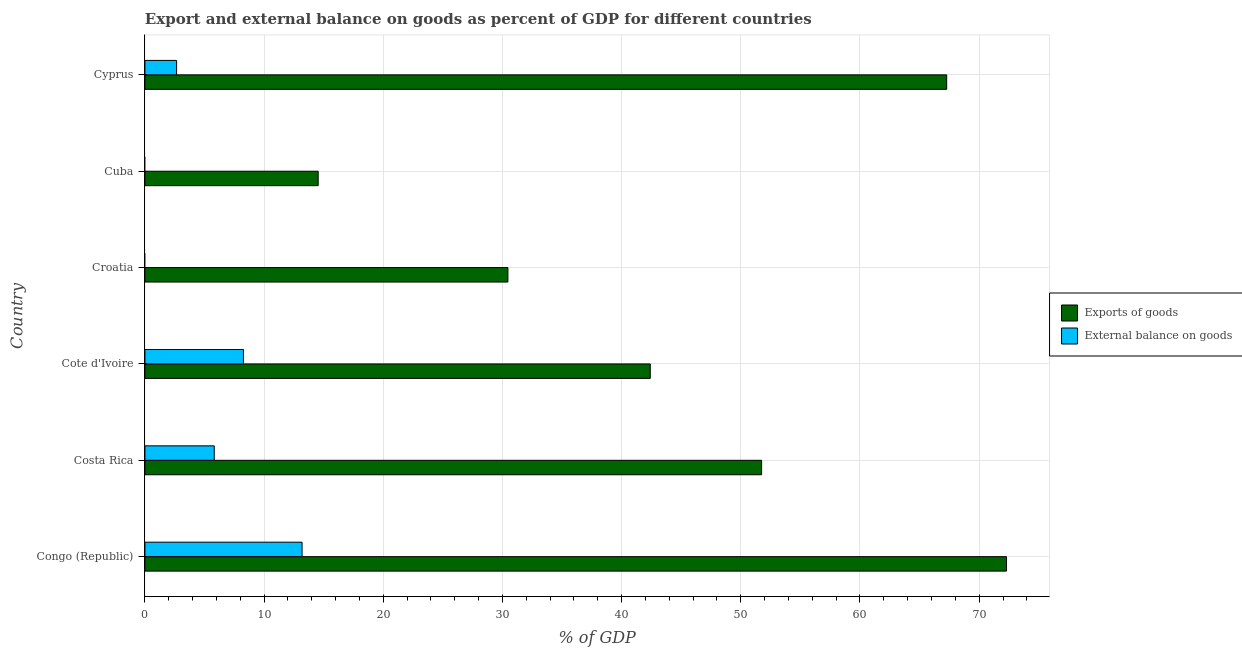How many different coloured bars are there?
Your answer should be very brief. 2. How many bars are there on the 3rd tick from the bottom?
Your response must be concise. 2. What is the label of the 2nd group of bars from the top?
Your response must be concise. Cuba. In how many cases, is the number of bars for a given country not equal to the number of legend labels?
Your answer should be compact. 2. What is the export of goods as percentage of gdp in Cote d'Ivoire?
Provide a succinct answer. 42.4. Across all countries, what is the maximum export of goods as percentage of gdp?
Make the answer very short. 72.29. Across all countries, what is the minimum export of goods as percentage of gdp?
Provide a short and direct response. 14.54. In which country was the external balance on goods as percentage of gdp maximum?
Your response must be concise. Congo (Republic). What is the total external balance on goods as percentage of gdp in the graph?
Provide a succinct answer. 29.93. What is the difference between the external balance on goods as percentage of gdp in Costa Rica and that in Cote d'Ivoire?
Your answer should be compact. -2.45. What is the difference between the export of goods as percentage of gdp in Costa Rica and the external balance on goods as percentage of gdp in Cuba?
Your response must be concise. 51.74. What is the average export of goods as percentage of gdp per country?
Your answer should be compact. 46.45. What is the difference between the external balance on goods as percentage of gdp and export of goods as percentage of gdp in Cote d'Ivoire?
Ensure brevity in your answer.  -34.14. What is the ratio of the export of goods as percentage of gdp in Congo (Republic) to that in Costa Rica?
Your answer should be compact. 1.4. Is the difference between the external balance on goods as percentage of gdp in Cote d'Ivoire and Cyprus greater than the difference between the export of goods as percentage of gdp in Cote d'Ivoire and Cyprus?
Make the answer very short. Yes. What is the difference between the highest and the second highest external balance on goods as percentage of gdp?
Keep it short and to the point. 4.92. What is the difference between the highest and the lowest export of goods as percentage of gdp?
Your answer should be compact. 57.75. How many bars are there?
Ensure brevity in your answer.  10. Are all the bars in the graph horizontal?
Provide a short and direct response. Yes. What is the difference between two consecutive major ticks on the X-axis?
Provide a succinct answer. 10. Does the graph contain any zero values?
Your answer should be very brief. Yes. How many legend labels are there?
Make the answer very short. 2. How are the legend labels stacked?
Your response must be concise. Vertical. What is the title of the graph?
Your answer should be very brief. Export and external balance on goods as percent of GDP for different countries. Does "Male labourers" appear as one of the legend labels in the graph?
Your response must be concise. No. What is the label or title of the X-axis?
Your answer should be very brief. % of GDP. What is the label or title of the Y-axis?
Ensure brevity in your answer.  Country. What is the % of GDP of Exports of goods in Congo (Republic)?
Offer a very short reply. 72.29. What is the % of GDP of External balance on goods in Congo (Republic)?
Offer a very short reply. 13.19. What is the % of GDP in Exports of goods in Costa Rica?
Offer a very short reply. 51.74. What is the % of GDP of External balance on goods in Costa Rica?
Your answer should be compact. 5.82. What is the % of GDP of Exports of goods in Cote d'Ivoire?
Offer a terse response. 42.4. What is the % of GDP in External balance on goods in Cote d'Ivoire?
Your response must be concise. 8.26. What is the % of GDP of Exports of goods in Croatia?
Your answer should be very brief. 30.46. What is the % of GDP of External balance on goods in Croatia?
Your answer should be very brief. 0. What is the % of GDP of Exports of goods in Cuba?
Give a very brief answer. 14.54. What is the % of GDP of Exports of goods in Cyprus?
Provide a short and direct response. 67.27. What is the % of GDP in External balance on goods in Cyprus?
Your answer should be compact. 2.66. Across all countries, what is the maximum % of GDP of Exports of goods?
Make the answer very short. 72.29. Across all countries, what is the maximum % of GDP in External balance on goods?
Your response must be concise. 13.19. Across all countries, what is the minimum % of GDP of Exports of goods?
Give a very brief answer. 14.54. Across all countries, what is the minimum % of GDP in External balance on goods?
Your answer should be very brief. 0. What is the total % of GDP in Exports of goods in the graph?
Keep it short and to the point. 278.71. What is the total % of GDP in External balance on goods in the graph?
Give a very brief answer. 29.93. What is the difference between the % of GDP in Exports of goods in Congo (Republic) and that in Costa Rica?
Your response must be concise. 20.55. What is the difference between the % of GDP in External balance on goods in Congo (Republic) and that in Costa Rica?
Your response must be concise. 7.37. What is the difference between the % of GDP in Exports of goods in Congo (Republic) and that in Cote d'Ivoire?
Offer a very short reply. 29.89. What is the difference between the % of GDP of External balance on goods in Congo (Republic) and that in Cote d'Ivoire?
Provide a succinct answer. 4.92. What is the difference between the % of GDP of Exports of goods in Congo (Republic) and that in Croatia?
Provide a short and direct response. 41.83. What is the difference between the % of GDP in Exports of goods in Congo (Republic) and that in Cuba?
Your answer should be compact. 57.75. What is the difference between the % of GDP in Exports of goods in Congo (Republic) and that in Cyprus?
Your answer should be very brief. 5.02. What is the difference between the % of GDP of External balance on goods in Congo (Republic) and that in Cyprus?
Provide a short and direct response. 10.53. What is the difference between the % of GDP in Exports of goods in Costa Rica and that in Cote d'Ivoire?
Keep it short and to the point. 9.34. What is the difference between the % of GDP in External balance on goods in Costa Rica and that in Cote d'Ivoire?
Make the answer very short. -2.45. What is the difference between the % of GDP in Exports of goods in Costa Rica and that in Croatia?
Provide a short and direct response. 21.29. What is the difference between the % of GDP in Exports of goods in Costa Rica and that in Cuba?
Make the answer very short. 37.21. What is the difference between the % of GDP of Exports of goods in Costa Rica and that in Cyprus?
Ensure brevity in your answer.  -15.53. What is the difference between the % of GDP in External balance on goods in Costa Rica and that in Cyprus?
Give a very brief answer. 3.16. What is the difference between the % of GDP in Exports of goods in Cote d'Ivoire and that in Croatia?
Your response must be concise. 11.95. What is the difference between the % of GDP of Exports of goods in Cote d'Ivoire and that in Cuba?
Make the answer very short. 27.87. What is the difference between the % of GDP of Exports of goods in Cote d'Ivoire and that in Cyprus?
Give a very brief answer. -24.87. What is the difference between the % of GDP of External balance on goods in Cote d'Ivoire and that in Cyprus?
Your response must be concise. 5.61. What is the difference between the % of GDP of Exports of goods in Croatia and that in Cuba?
Your answer should be compact. 15.92. What is the difference between the % of GDP of Exports of goods in Croatia and that in Cyprus?
Offer a terse response. -36.82. What is the difference between the % of GDP of Exports of goods in Cuba and that in Cyprus?
Your answer should be compact. -52.74. What is the difference between the % of GDP of Exports of goods in Congo (Republic) and the % of GDP of External balance on goods in Costa Rica?
Your answer should be compact. 66.47. What is the difference between the % of GDP of Exports of goods in Congo (Republic) and the % of GDP of External balance on goods in Cote d'Ivoire?
Make the answer very short. 64.03. What is the difference between the % of GDP in Exports of goods in Congo (Republic) and the % of GDP in External balance on goods in Cyprus?
Provide a short and direct response. 69.63. What is the difference between the % of GDP of Exports of goods in Costa Rica and the % of GDP of External balance on goods in Cote d'Ivoire?
Provide a succinct answer. 43.48. What is the difference between the % of GDP in Exports of goods in Costa Rica and the % of GDP in External balance on goods in Cyprus?
Make the answer very short. 49.09. What is the difference between the % of GDP of Exports of goods in Cote d'Ivoire and the % of GDP of External balance on goods in Cyprus?
Provide a succinct answer. 39.75. What is the difference between the % of GDP of Exports of goods in Croatia and the % of GDP of External balance on goods in Cyprus?
Ensure brevity in your answer.  27.8. What is the difference between the % of GDP in Exports of goods in Cuba and the % of GDP in External balance on goods in Cyprus?
Give a very brief answer. 11.88. What is the average % of GDP of Exports of goods per country?
Offer a terse response. 46.45. What is the average % of GDP of External balance on goods per country?
Provide a short and direct response. 4.99. What is the difference between the % of GDP in Exports of goods and % of GDP in External balance on goods in Congo (Republic)?
Your answer should be very brief. 59.1. What is the difference between the % of GDP in Exports of goods and % of GDP in External balance on goods in Costa Rica?
Your answer should be compact. 45.93. What is the difference between the % of GDP of Exports of goods and % of GDP of External balance on goods in Cote d'Ivoire?
Make the answer very short. 34.14. What is the difference between the % of GDP of Exports of goods and % of GDP of External balance on goods in Cyprus?
Keep it short and to the point. 64.62. What is the ratio of the % of GDP of Exports of goods in Congo (Republic) to that in Costa Rica?
Offer a very short reply. 1.4. What is the ratio of the % of GDP of External balance on goods in Congo (Republic) to that in Costa Rica?
Make the answer very short. 2.27. What is the ratio of the % of GDP in Exports of goods in Congo (Republic) to that in Cote d'Ivoire?
Provide a succinct answer. 1.7. What is the ratio of the % of GDP of External balance on goods in Congo (Republic) to that in Cote d'Ivoire?
Make the answer very short. 1.6. What is the ratio of the % of GDP of Exports of goods in Congo (Republic) to that in Croatia?
Offer a very short reply. 2.37. What is the ratio of the % of GDP in Exports of goods in Congo (Republic) to that in Cuba?
Offer a very short reply. 4.97. What is the ratio of the % of GDP in Exports of goods in Congo (Republic) to that in Cyprus?
Offer a very short reply. 1.07. What is the ratio of the % of GDP of External balance on goods in Congo (Republic) to that in Cyprus?
Provide a short and direct response. 4.96. What is the ratio of the % of GDP in Exports of goods in Costa Rica to that in Cote d'Ivoire?
Offer a terse response. 1.22. What is the ratio of the % of GDP in External balance on goods in Costa Rica to that in Cote d'Ivoire?
Offer a very short reply. 0.7. What is the ratio of the % of GDP in Exports of goods in Costa Rica to that in Croatia?
Make the answer very short. 1.7. What is the ratio of the % of GDP of Exports of goods in Costa Rica to that in Cuba?
Give a very brief answer. 3.56. What is the ratio of the % of GDP of Exports of goods in Costa Rica to that in Cyprus?
Keep it short and to the point. 0.77. What is the ratio of the % of GDP of External balance on goods in Costa Rica to that in Cyprus?
Make the answer very short. 2.19. What is the ratio of the % of GDP in Exports of goods in Cote d'Ivoire to that in Croatia?
Provide a short and direct response. 1.39. What is the ratio of the % of GDP in Exports of goods in Cote d'Ivoire to that in Cuba?
Make the answer very short. 2.92. What is the ratio of the % of GDP of Exports of goods in Cote d'Ivoire to that in Cyprus?
Provide a short and direct response. 0.63. What is the ratio of the % of GDP of External balance on goods in Cote d'Ivoire to that in Cyprus?
Ensure brevity in your answer.  3.11. What is the ratio of the % of GDP of Exports of goods in Croatia to that in Cuba?
Give a very brief answer. 2.1. What is the ratio of the % of GDP in Exports of goods in Croatia to that in Cyprus?
Ensure brevity in your answer.  0.45. What is the ratio of the % of GDP in Exports of goods in Cuba to that in Cyprus?
Provide a succinct answer. 0.22. What is the difference between the highest and the second highest % of GDP in Exports of goods?
Make the answer very short. 5.02. What is the difference between the highest and the second highest % of GDP of External balance on goods?
Provide a succinct answer. 4.92. What is the difference between the highest and the lowest % of GDP of Exports of goods?
Keep it short and to the point. 57.75. What is the difference between the highest and the lowest % of GDP of External balance on goods?
Keep it short and to the point. 13.19. 